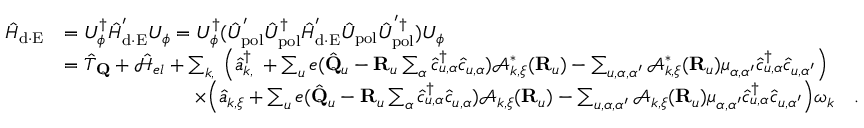Convert formula to latex. <formula><loc_0><loc_0><loc_500><loc_500>\begin{array} { r l } { \hat { H } _ { d \cdot E } } & { = U _ { \phi } ^ { \dagger } \hat { H } _ { d \cdot E } ^ { ^ { \prime } } U _ { \phi } = U _ { \phi } ^ { \dagger } ( \hat { U } _ { p o l } ^ { ^ { \prime } } \hat { U } _ { p o l } ^ { \dagger } \hat { H } _ { d \cdot E } ^ { ^ { \prime } } \hat { U } _ { p o l } \hat { U } _ { p o l } ^ { ^ { \prime } \dagger } ) U _ { \phi } } \\ & { = \hat { T } _ { Q } + \mathcal { \hat { H } } _ { e l } + \sum _ { { \boldsymbol k } , { \xi } } \left ( \hat { a } _ { { \boldsymbol k } , { \xi } } ^ { \dagger } + \sum _ { u } e ( \hat { Q } _ { u } - { R } _ { u } \sum _ { \alpha } \hat { c } _ { u , \alpha } ^ { \dagger } \hat { c } _ { u , \alpha } ) \mathcal { A } _ { { \boldsymbol k } , { \boldsymbol \xi } } ^ { * } ( { R } _ { u } ) - \sum _ { u , \alpha , \alpha ^ { \prime } } \mathcal { A } _ { { \boldsymbol k } , { \boldsymbol \xi } } ^ { * } ( { R } _ { u } ) { \boldsymbol \mu } _ { \alpha , \alpha ^ { \prime } } \hat { c } _ { u , \alpha } ^ { \dagger } \hat { c } _ { u , \alpha ^ { \prime } } \right ) } \\ & { \times \left ( \hat { a } _ { { \boldsymbol k } , { \xi } } + \sum _ { u } e ( \hat { Q } _ { u } - { R } _ { u } \sum _ { \alpha } \hat { c } _ { u , \alpha } ^ { \dagger } \hat { c } _ { u , \alpha } ) \mathcal { A } _ { { \boldsymbol k } , { \boldsymbol \xi } } ( { R } _ { u } ) - \sum _ { u , \alpha , \alpha ^ { \prime } } \mathcal { A } _ { { \boldsymbol k } , { \boldsymbol \xi } } ( { R } _ { u } ) { \boldsymbol \mu } _ { \alpha , \alpha ^ { \prime } } \hat { c } _ { u , \alpha } ^ { \dagger } \hat { c } _ { u , \alpha ^ { \prime } } \right ) \omega _ { \boldsymbol k } . } \end{array}</formula> 